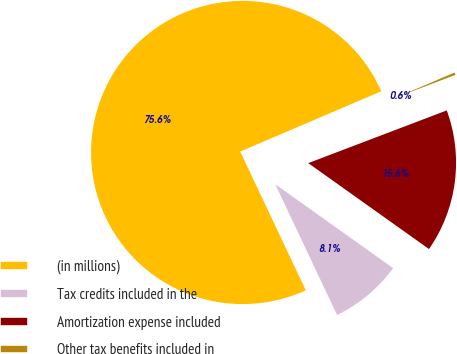Convert chart. <chart><loc_0><loc_0><loc_500><loc_500><pie_chart><fcel>(in millions)<fcel>Tax credits included in the<fcel>Amortization expense included<fcel>Other tax benefits included in<nl><fcel>75.6%<fcel>8.13%<fcel>15.63%<fcel>0.64%<nl></chart> 